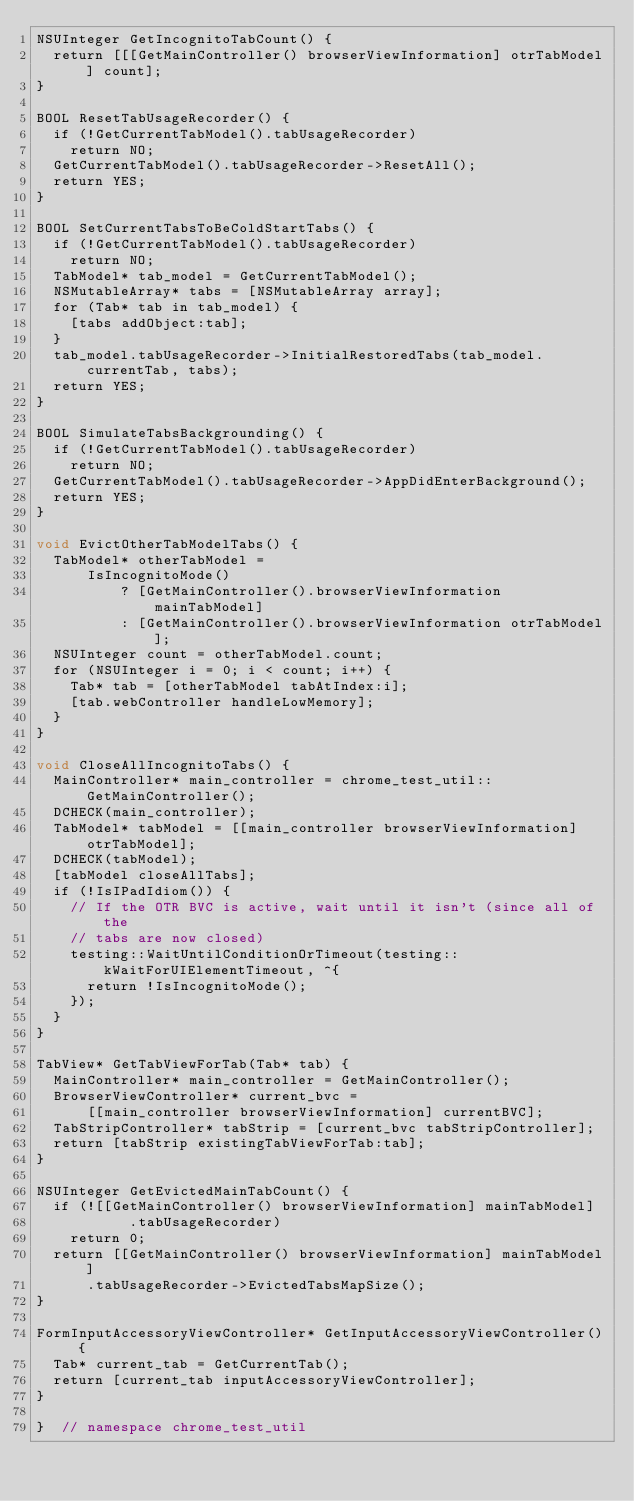<code> <loc_0><loc_0><loc_500><loc_500><_ObjectiveC_>NSUInteger GetIncognitoTabCount() {
  return [[[GetMainController() browserViewInformation] otrTabModel] count];
}

BOOL ResetTabUsageRecorder() {
  if (!GetCurrentTabModel().tabUsageRecorder)
    return NO;
  GetCurrentTabModel().tabUsageRecorder->ResetAll();
  return YES;
}

BOOL SetCurrentTabsToBeColdStartTabs() {
  if (!GetCurrentTabModel().tabUsageRecorder)
    return NO;
  TabModel* tab_model = GetCurrentTabModel();
  NSMutableArray* tabs = [NSMutableArray array];
  for (Tab* tab in tab_model) {
    [tabs addObject:tab];
  }
  tab_model.tabUsageRecorder->InitialRestoredTabs(tab_model.currentTab, tabs);
  return YES;
}

BOOL SimulateTabsBackgrounding() {
  if (!GetCurrentTabModel().tabUsageRecorder)
    return NO;
  GetCurrentTabModel().tabUsageRecorder->AppDidEnterBackground();
  return YES;
}

void EvictOtherTabModelTabs() {
  TabModel* otherTabModel =
      IsIncognitoMode()
          ? [GetMainController().browserViewInformation mainTabModel]
          : [GetMainController().browserViewInformation otrTabModel];
  NSUInteger count = otherTabModel.count;
  for (NSUInteger i = 0; i < count; i++) {
    Tab* tab = [otherTabModel tabAtIndex:i];
    [tab.webController handleLowMemory];
  }
}

void CloseAllIncognitoTabs() {
  MainController* main_controller = chrome_test_util::GetMainController();
  DCHECK(main_controller);
  TabModel* tabModel = [[main_controller browserViewInformation] otrTabModel];
  DCHECK(tabModel);
  [tabModel closeAllTabs];
  if (!IsIPadIdiom()) {
    // If the OTR BVC is active, wait until it isn't (since all of the
    // tabs are now closed)
    testing::WaitUntilConditionOrTimeout(testing::kWaitForUIElementTimeout, ^{
      return !IsIncognitoMode();
    });
  }
}

TabView* GetTabViewForTab(Tab* tab) {
  MainController* main_controller = GetMainController();
  BrowserViewController* current_bvc =
      [[main_controller browserViewInformation] currentBVC];
  TabStripController* tabStrip = [current_bvc tabStripController];
  return [tabStrip existingTabViewForTab:tab];
}

NSUInteger GetEvictedMainTabCount() {
  if (![[GetMainController() browserViewInformation] mainTabModel]
           .tabUsageRecorder)
    return 0;
  return [[GetMainController() browserViewInformation] mainTabModel]
      .tabUsageRecorder->EvictedTabsMapSize();
}

FormInputAccessoryViewController* GetInputAccessoryViewController() {
  Tab* current_tab = GetCurrentTab();
  return [current_tab inputAccessoryViewController];
}

}  // namespace chrome_test_util
</code> 